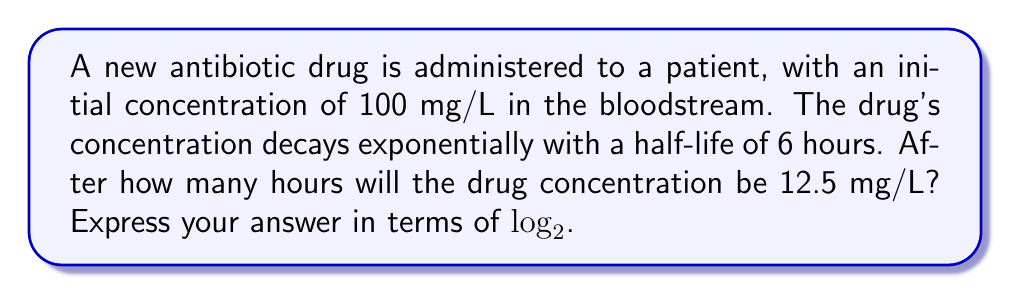Can you solve this math problem? Let's approach this step-by-step:

1) The general formula for exponential decay is:
   $$C(t) = C_0 \cdot 2^{-t/t_{1/2}}$$
   where $C(t)$ is the concentration at time $t$, $C_0$ is the initial concentration, and $t_{1/2}$ is the half-life.

2) We're given:
   $C_0 = 100$ mg/L
   $t_{1/2} = 6$ hours
   $C(t) = 12.5$ mg/L

3) Plugging these into our formula:
   $$12.5 = 100 \cdot 2^{-t/6}$$

4) Dividing both sides by 100:
   $$0.125 = 2^{-t/6}$$

5) Taking $\log_2$ of both sides:
   $$\log_2(0.125) = -t/6$$

6) Simplify the left side:
   $$-3 = -t/6$$
   (Because $2^{-3} = 0.125$)

7) Multiply both sides by -6:
   $$18 = t$$

8) To express this in terms of $\log_2$ as requested:
   $$t = 6 \cdot \log_2(100/12.5) = 6 \cdot \log_2(8) = 6 \cdot 3 = 18$$

Thus, it will take 18 hours for the concentration to reach 12.5 mg/L.
Answer: $6 \cdot \log_2(8)$ hours 